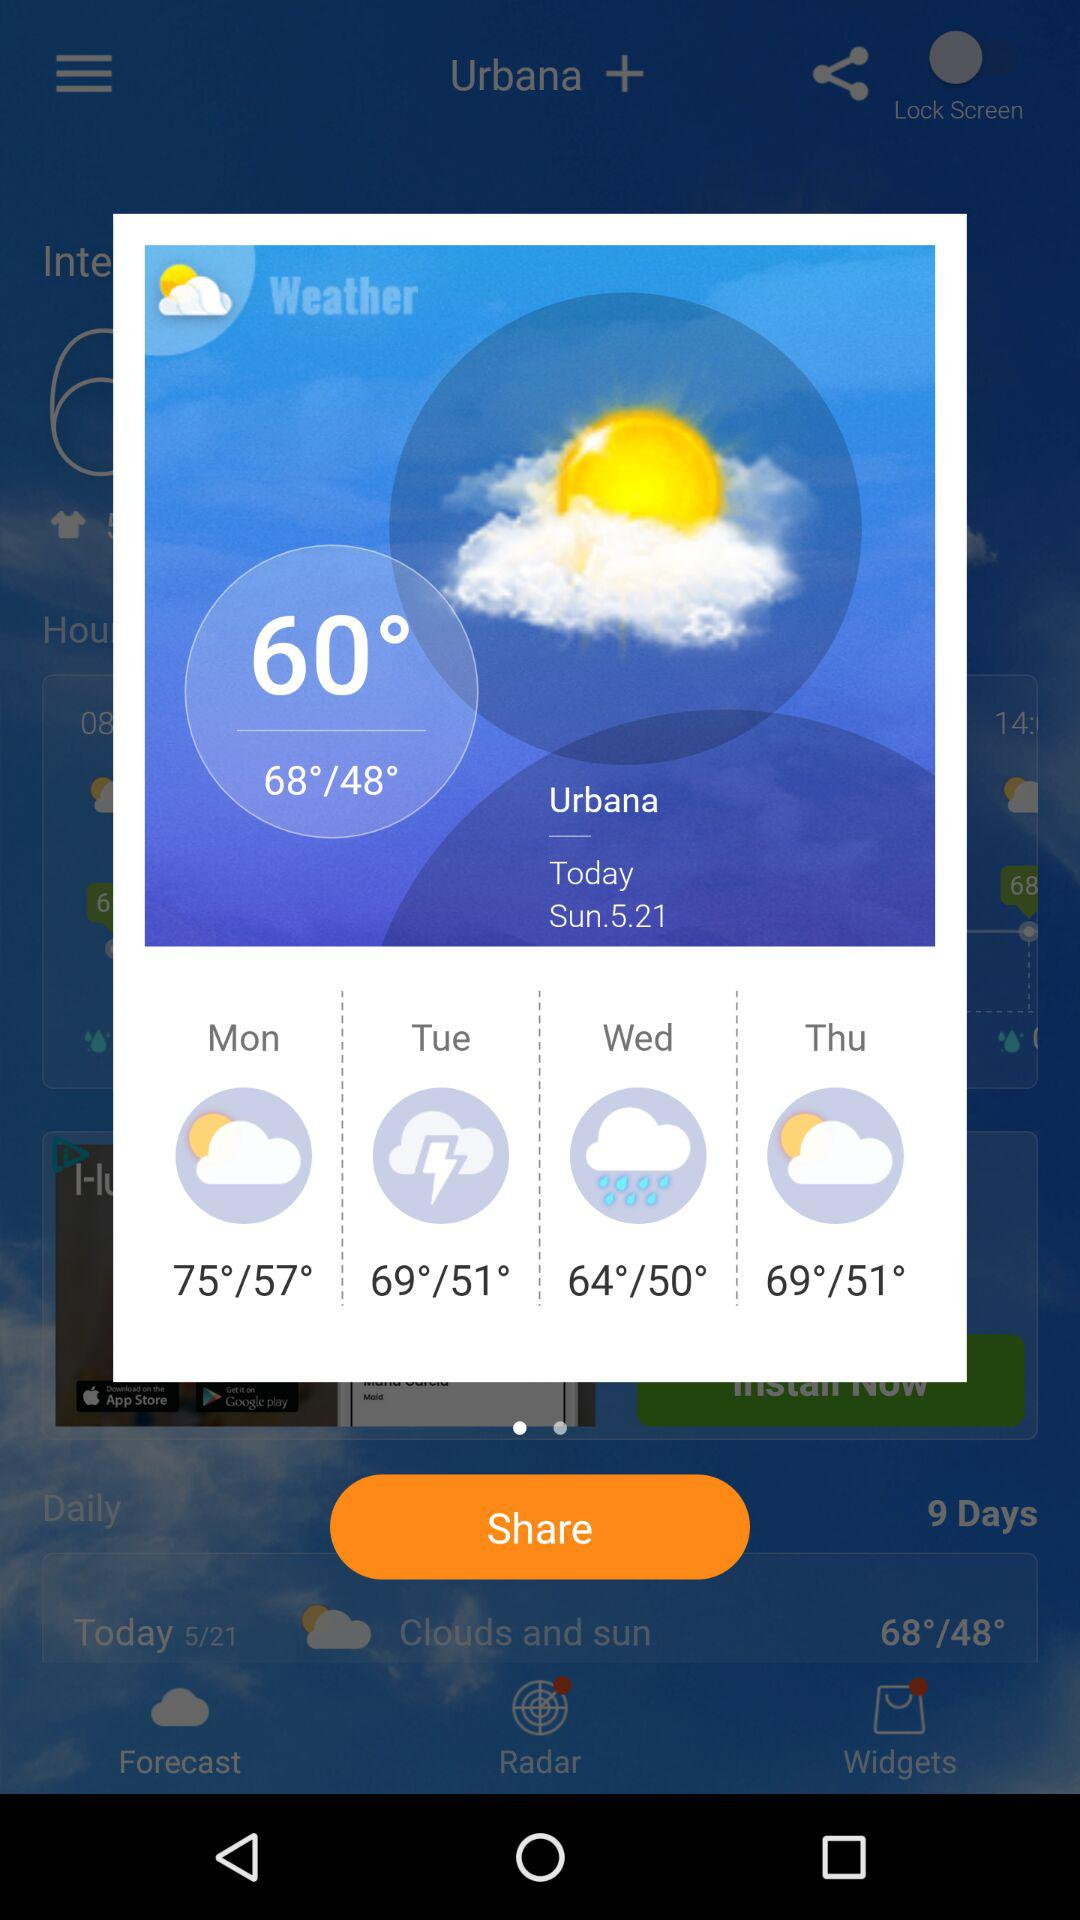What is the temperature on Sunday? The temperature on Sunday is 60°. 